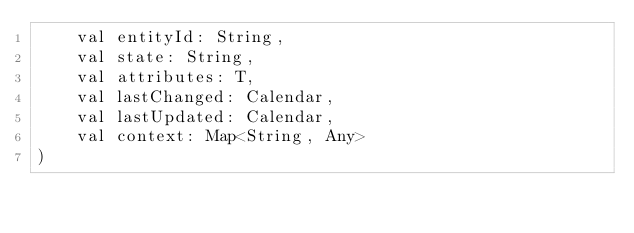Convert code to text. <code><loc_0><loc_0><loc_500><loc_500><_Kotlin_>    val entityId: String,
    val state: String,
    val attributes: T,
    val lastChanged: Calendar,
    val lastUpdated: Calendar,
    val context: Map<String, Any>
)
</code> 